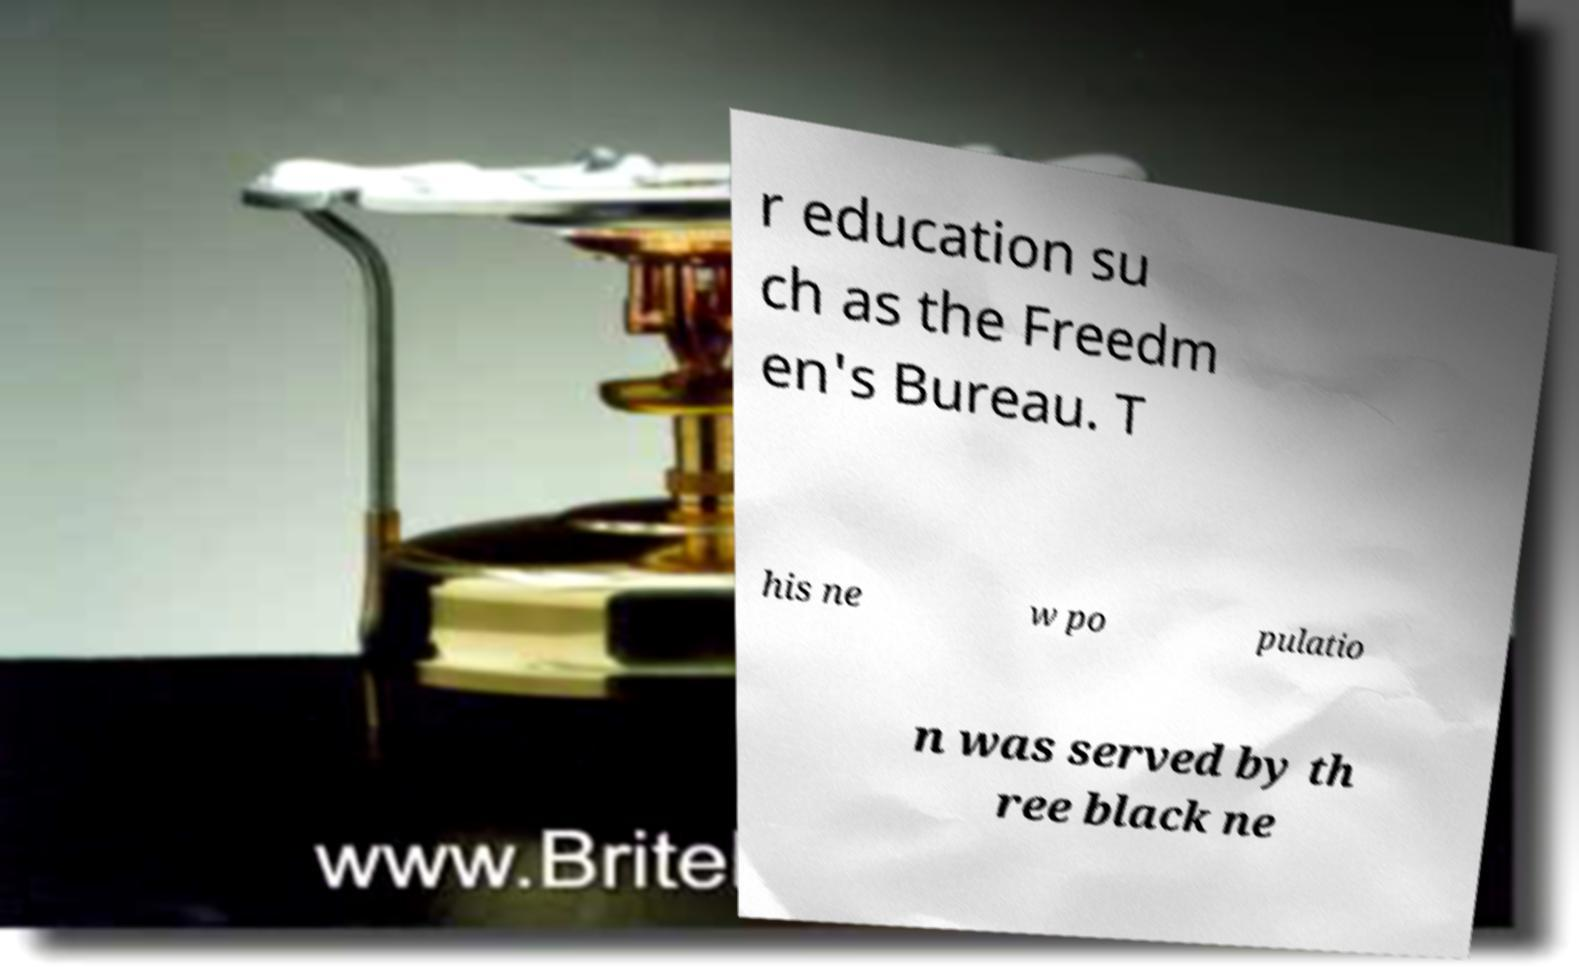What messages or text are displayed in this image? I need them in a readable, typed format. r education su ch as the Freedm en's Bureau. T his ne w po pulatio n was served by th ree black ne 